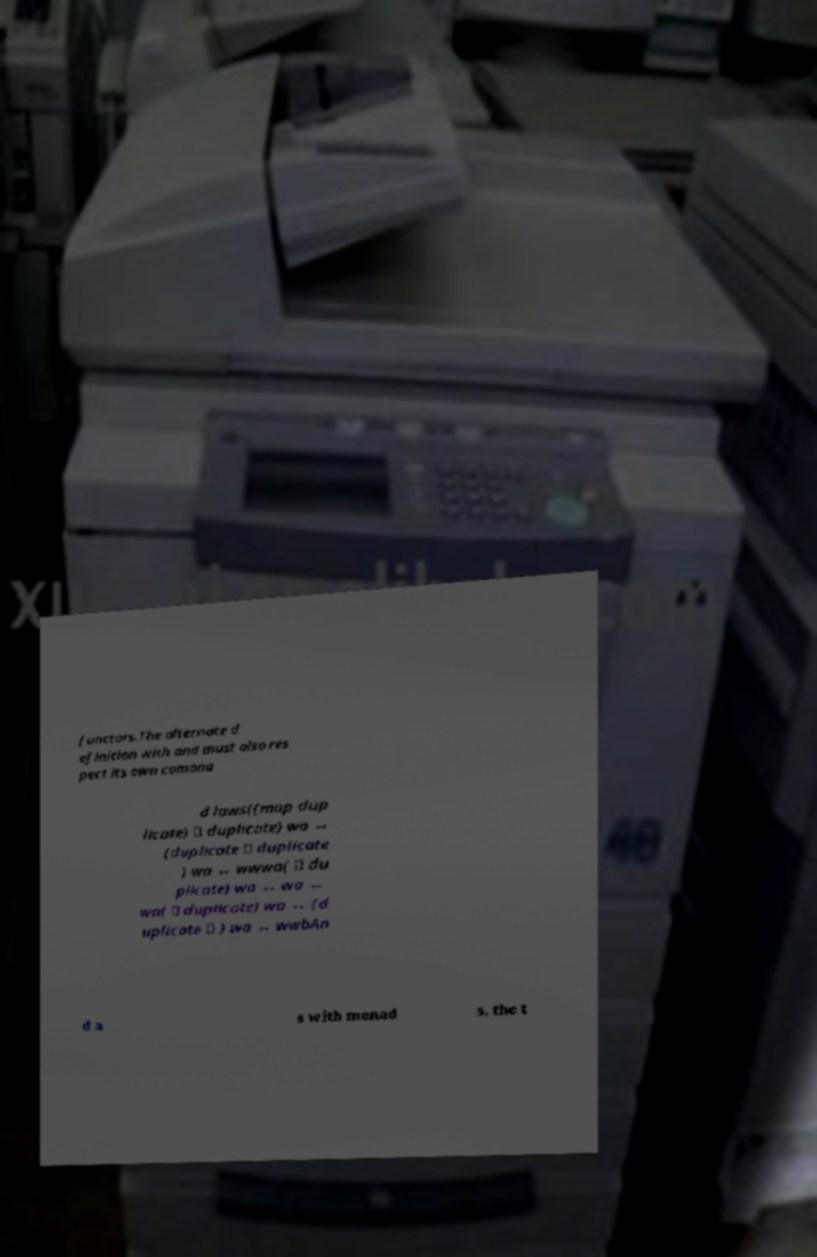For documentation purposes, I need the text within this image transcribed. Could you provide that? functors.The alternate d efinition with and must also res pect its own comona d laws((map dup licate) ∘ duplicate) wa ↔ (duplicate ∘ duplicate ) wa ↔ wwwa( ∘ du plicate) wa ↔ wa ↔ wa( ∘ duplicate) wa ↔ (d uplicate ∘ ) wa ↔ wwbAn d a s with monad s, the t 